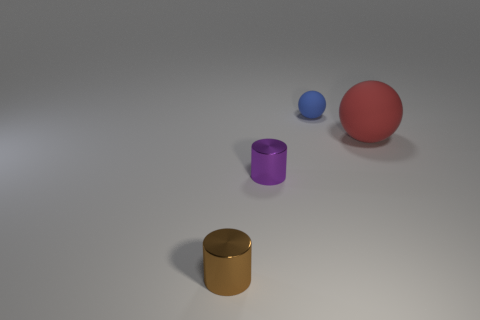Add 4 spheres. How many objects exist? 8 Add 4 large matte spheres. How many large matte spheres exist? 5 Subtract 1 purple cylinders. How many objects are left? 3 Subtract all tiny blue rubber spheres. Subtract all tiny brown metallic objects. How many objects are left? 2 Add 3 brown metal cylinders. How many brown metal cylinders are left? 4 